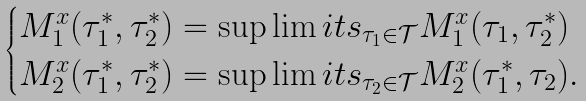<formula> <loc_0><loc_0><loc_500><loc_500>\begin{cases} M ^ { x } _ { 1 } ( \tau ^ { * } _ { 1 } , \tau ^ { * } _ { 2 } ) = \sup \lim i t s _ { \tau _ { 1 } \in \mathcal { T } } M ^ { x } _ { 1 } ( \tau _ { 1 } , \tau ^ { * } _ { 2 } ) \\ M ^ { x } _ { 2 } ( \tau ^ { * } _ { 1 } , \tau ^ { * } _ { 2 } ) = \sup \lim i t s _ { \tau _ { 2 } \in \mathcal { T } } M ^ { x } _ { 2 } ( \tau ^ { * } _ { 1 } , \tau _ { 2 } ) . \end{cases}</formula> 